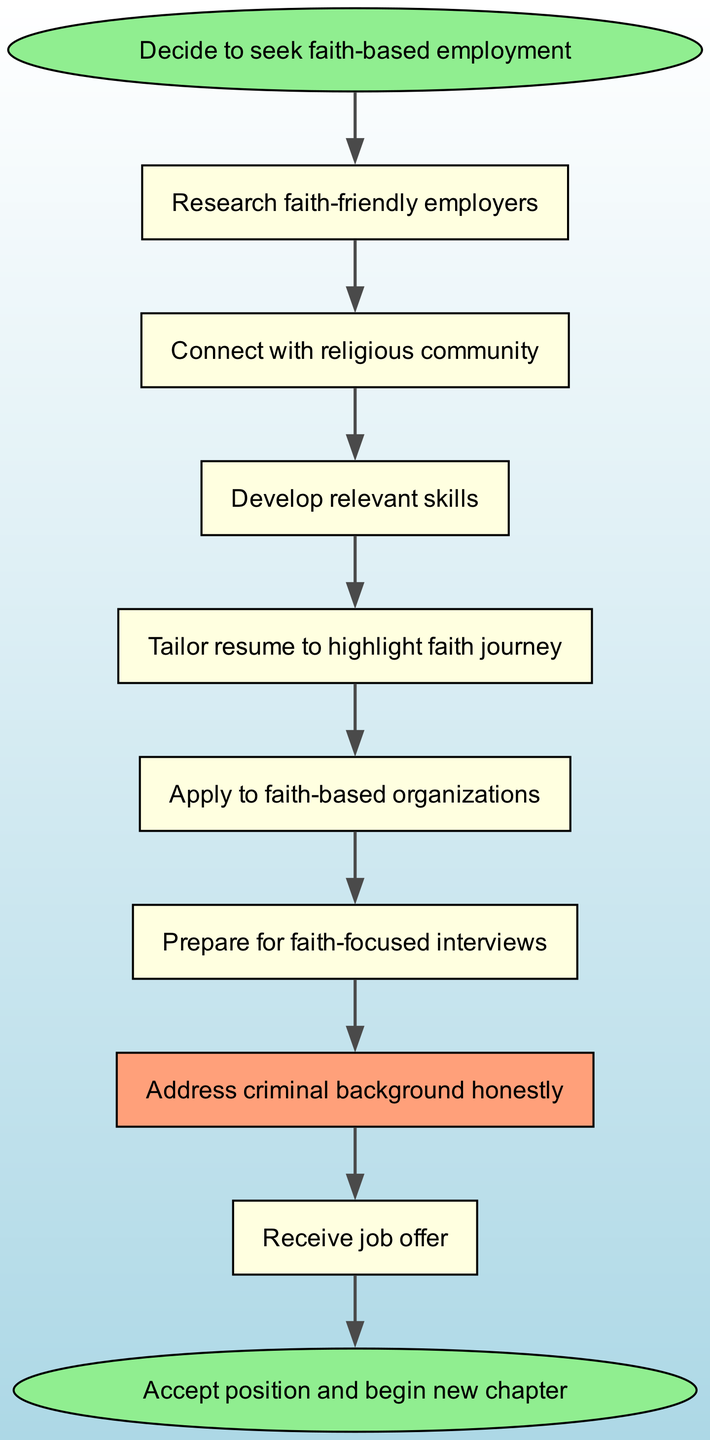What is the first step in the flow chart? The first step in the flow chart is represented by the node labeled "Decide to seek faith-based employment." This is the starting point of the process.
Answer: Decide to seek faith-based employment How many nodes are in the diagram? To find the number of nodes, count each distinct step in the flow chart from start to finish. There are ten elements listed that correspond to each node.
Answer: 10 Which node comes after "Apply to faith-based organizations"? The flow chart shows a direct connection from "Apply to faith-based organizations" to "Prepare for faith-focused interviews" as the next step in the sequence.
Answer: Prepare for faith-focused interviews How are "Connect with religious community" and "Develop relevant skills" related in the diagram? The diagram indicates a direct flow from "Connect with religious community" to "Develop relevant skills," suggesting that networking facilitates skill development.
Answer: They are sequentially connected What is the last step in the flow chart? The last step in the flow chart is represented by the node labeled "Accept position and begin new chapter," indicating the conclusion of this employment journey.
Answer: Accept position and begin new chapter What color is the node "Address criminal background honestly"? In the diagram, the node "Address criminal background honestly" is colored light salmon, which distinguishes it from other nodes.
Answer: Lightsalmon How many connections are there in the diagram? To determine the number of connections, count all the directed edges that link one node to another. The diagram lists nine connections.
Answer: 9 What is the relationship between the nodes "Prepare for faith-focused interviews" and "Receive job offer"? The diagram shows that "Prepare for faith-focused interviews" leads directly to "Receive job offer," indicating that preparation is a prerequisite for receiving a job offer.
Answer: Sequential connection What role does the node "Tailor resume to highlight faith journey" play in the process? The node "Tailor resume to highlight faith journey" serves as a key step that follows skills development, indicating that it emphasizes one's faith experience to enhance job applications.
Answer: Tailored resume development 